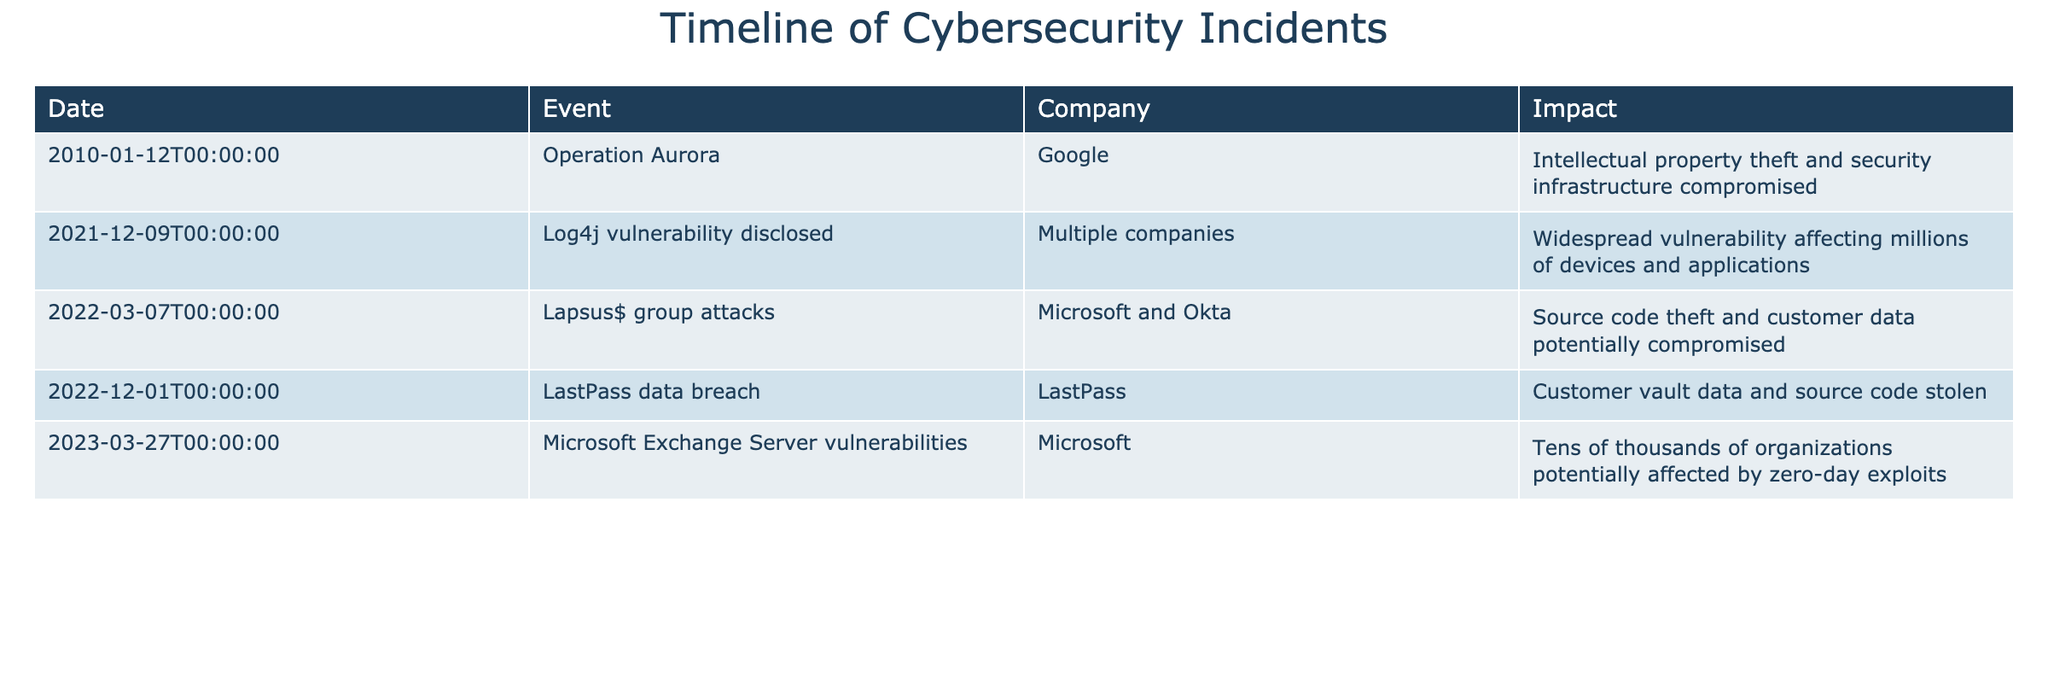What is the date of the Log4j vulnerability disclosure? The Log4j vulnerability was disclosed on December 9, 2021. I can find this information by looking at the table and locating the row with the "Log4j vulnerability disclosed" event.
Answer: December 9, 2021 Which company experienced the LastPass data breach? The company involved in the LastPass data breach is LastPass. This can be found by looking at the corresponding row under the "Company" column next to the event "LastPass data breach."
Answer: LastPass How many incidents involved Microsoft? There are three incidents involving Microsoft listed in the table: Operation Aurora, Lapsus$ group attacks, and Microsoft Exchange Server vulnerabilities. By counting the rows with Microsoft in the "Company" column, I find three such entries.
Answer: 3 Did the operation Aurora result in any intellectual property theft? Yes, the Operation Aurora resulted in intellectual property theft and compromised security infrastructure for Google. This information is stated directly in the "Impact" column for that specific event.
Answer: Yes Which incident had the greatest impact regarding customer data? The Lapsus$ group attacks and the LastPass data breach both resulted in potential compromise of customer data, but since both mentioned customer data, I will compare their descriptions. Both incidents can be considered equally impactful regarding customer data; however, it is less clear which was greater without further context.
Answer: Both had significant impacts What is the total number of incidents listed in the table? The table lists a total of five incidents. I can find this by counting the number of rows in the table, which correspond to each unique incident.
Answer: 5 Identify the incident with the widest vulnerability reported. The Log4j vulnerability affected millions of devices and applications, considered the widest vulnerability based on the description in the "Impact" column. I compared the impacts described for each incident to determine which had the most extensive effect.
Answer: Log4j vulnerability disclosed What percentage of the incidents listed impacted Microsoft? Three out of five incidents involved Microsoft. Therefore, I can calculate the percentage as (3/5)*100, which equals 60%. This requires simple division and multiplication based on the count of relevant incidents.
Answer: 60% Was the LastPass data breach a source code theft incident? No, the LastPass data breach involved customer vault data and source code being stolen, so it was not solely a source code theft incident. This distinction is made by reading the "Impact" description for LastPass.
Answer: No 